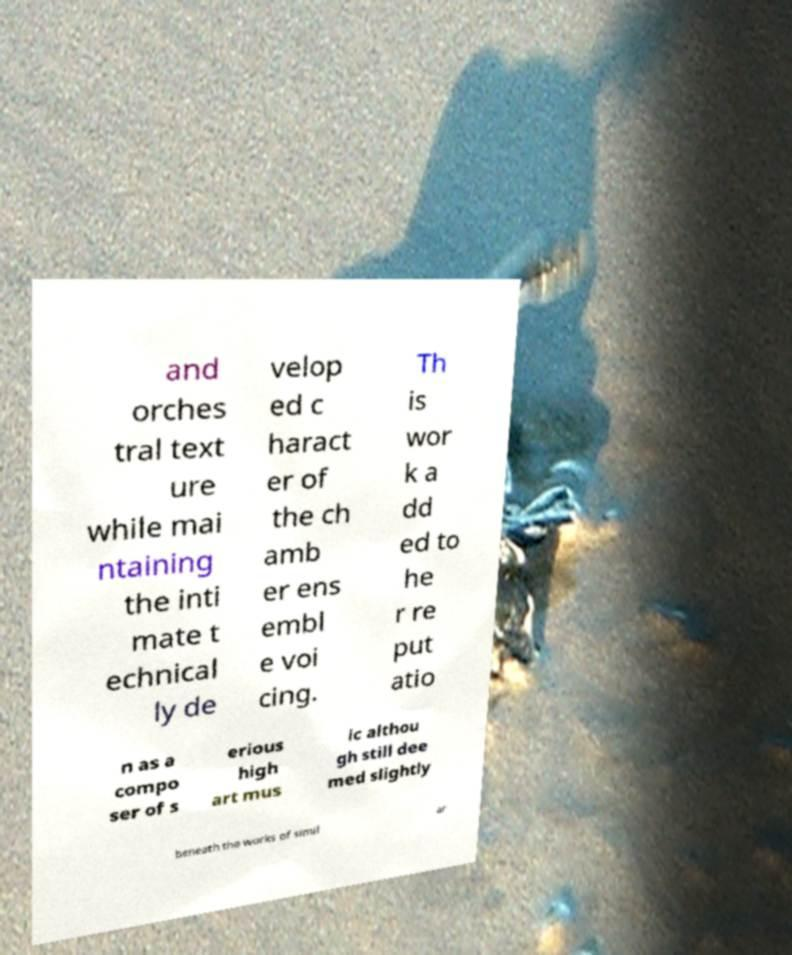Please identify and transcribe the text found in this image. and orches tral text ure while mai ntaining the inti mate t echnical ly de velop ed c haract er of the ch amb er ens embl e voi cing. Th is wor k a dd ed to he r re put atio n as a compo ser of s erious high art mus ic althou gh still dee med slightly beneath the works of simil ar 